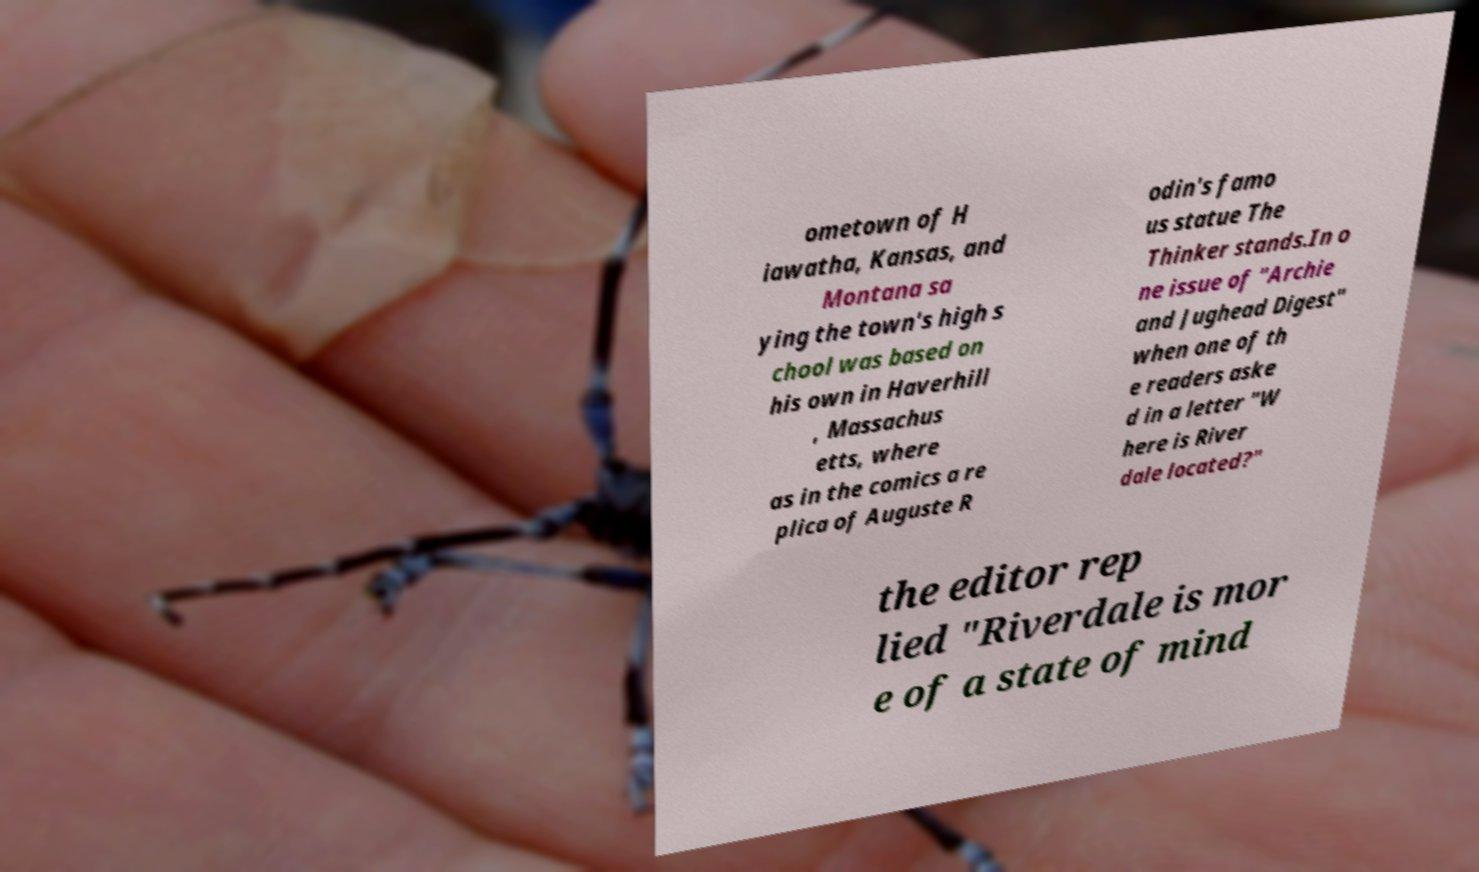Please identify and transcribe the text found in this image. ometown of H iawatha, Kansas, and Montana sa ying the town's high s chool was based on his own in Haverhill , Massachus etts, where as in the comics a re plica of Auguste R odin's famo us statue The Thinker stands.In o ne issue of "Archie and Jughead Digest" when one of th e readers aske d in a letter "W here is River dale located?" the editor rep lied "Riverdale is mor e of a state of mind 